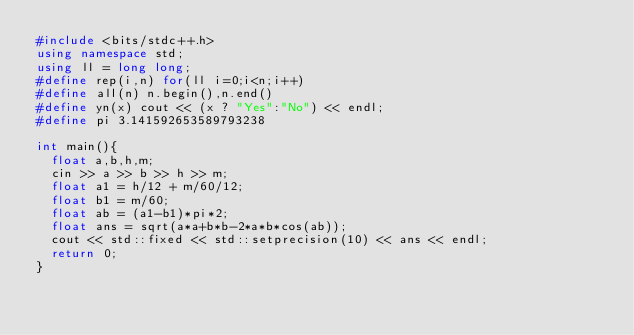Convert code to text. <code><loc_0><loc_0><loc_500><loc_500><_C++_>#include <bits/stdc++.h>
using namespace std;
using ll = long long;
#define rep(i,n) for(ll i=0;i<n;i++)
#define all(n) n.begin(),n.end()
#define yn(x) cout << (x ? "Yes":"No") << endl;
#define pi 3.141592653589793238

int main(){
  float a,b,h,m;
  cin >> a >> b >> h >> m;
  float a1 = h/12 + m/60/12;
  float b1 = m/60;
  float ab = (a1-b1)*pi*2;
  float ans = sqrt(a*a+b*b-2*a*b*cos(ab));
  cout << std::fixed << std::setprecision(10) << ans << endl;
  return 0;
}
</code> 